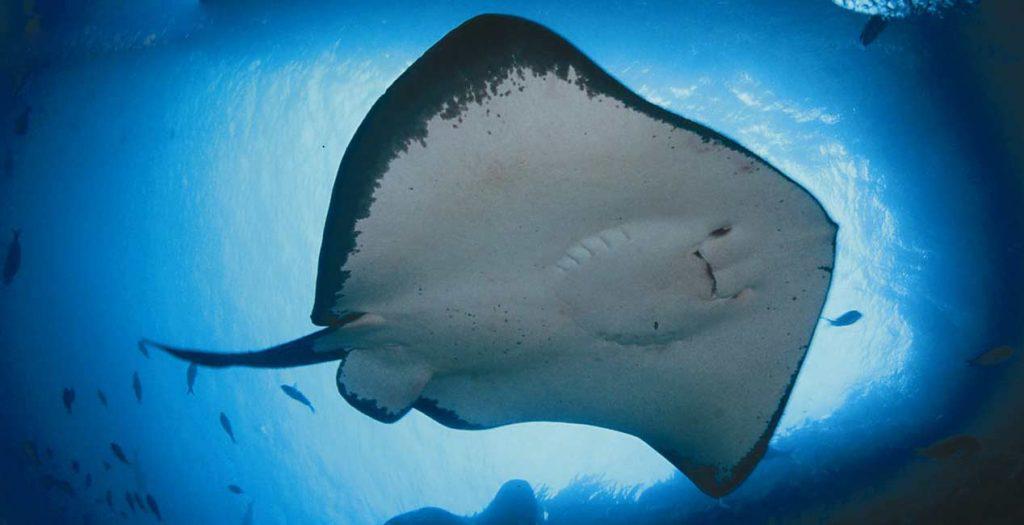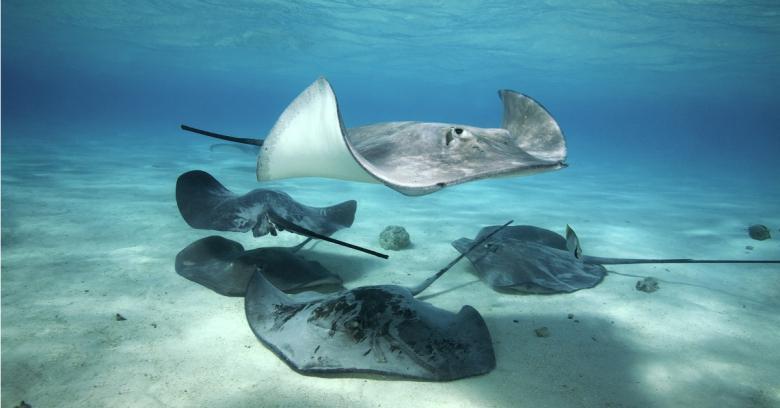The first image is the image on the left, the second image is the image on the right. Assess this claim about the two images: "The left and right image contains no more than three stingrays.". Correct or not? Answer yes or no. No. The first image is the image on the left, the second image is the image on the right. Considering the images on both sides, is "No image contains more than two stingray, and one image shows the underside of at least one stingray, while the other image shows the top of at least one stingray." valid? Answer yes or no. No. 